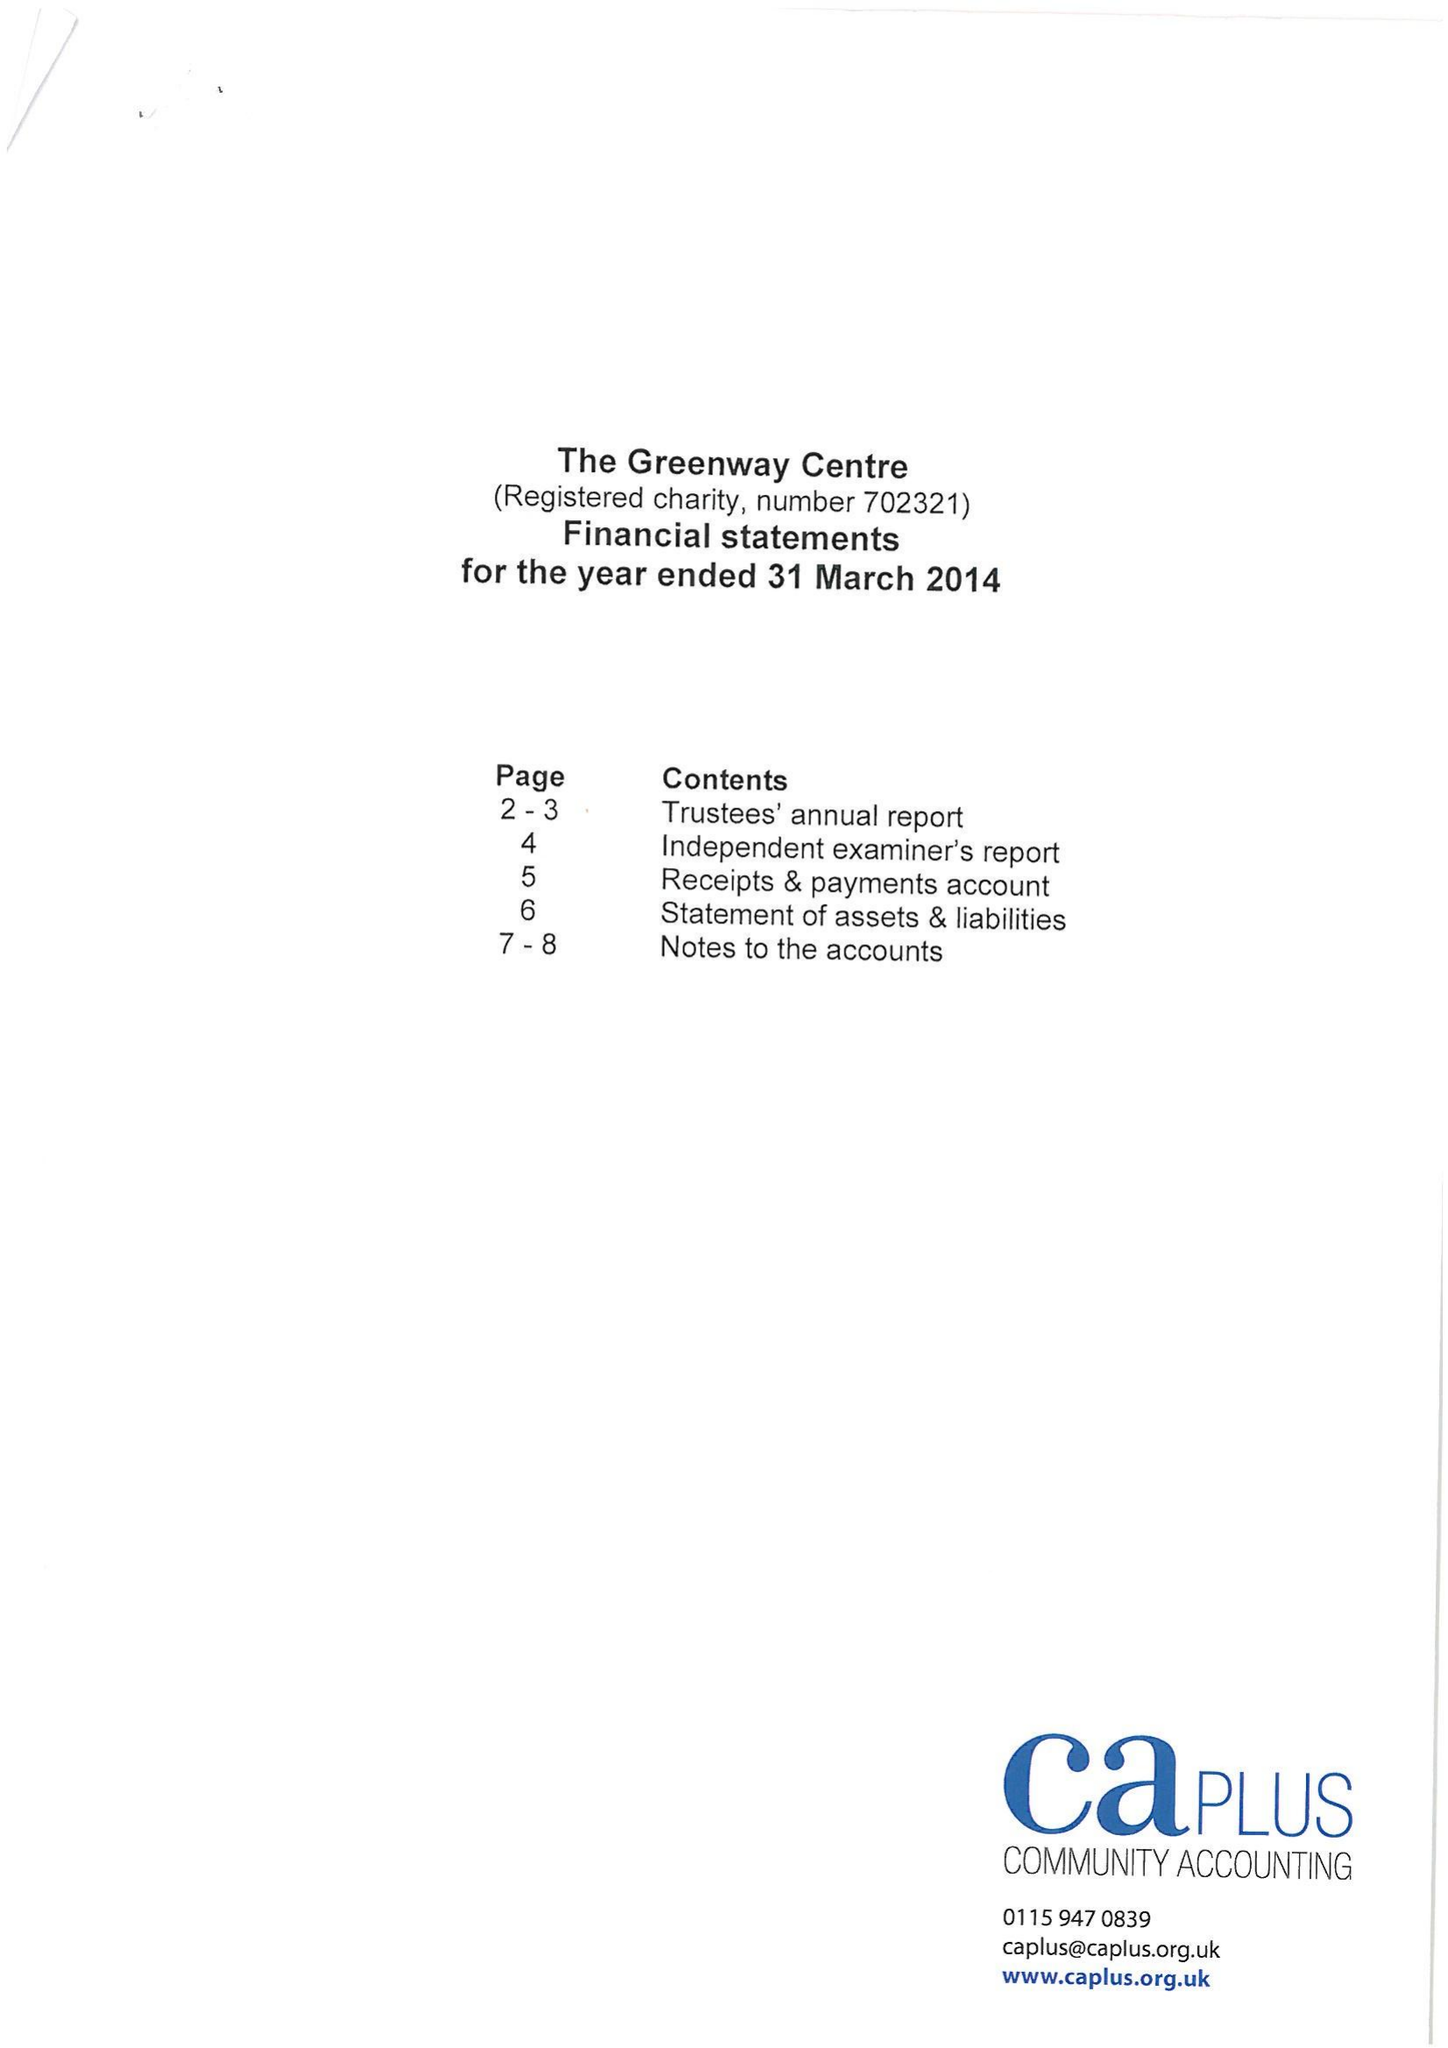What is the value for the address__postcode?
Answer the question using a single word or phrase. NG2 4NB 